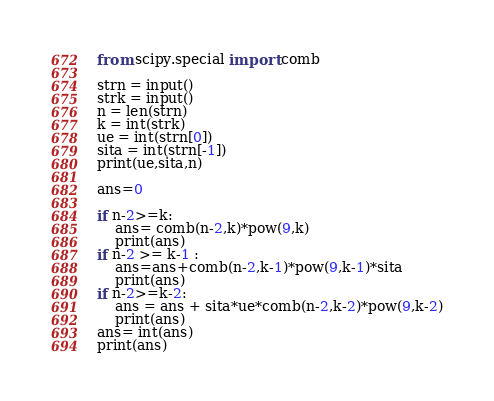Convert code to text. <code><loc_0><loc_0><loc_500><loc_500><_Python_>from scipy.special import comb

strn = input()
strk = input()
n = len(strn)
k = int(strk)
ue = int(strn[0])
sita = int(strn[-1])
print(ue,sita,n)

ans=0

if n-2>=k:
    ans= comb(n-2,k)*pow(9,k)
    print(ans)
if n-2 >= k-1 :
    ans=ans+comb(n-2,k-1)*pow(9,k-1)*sita
    print(ans)
if n-2>=k-2:
    ans = ans + sita*ue*comb(n-2,k-2)*pow(9,k-2)
    print(ans)
ans= int(ans)
print(ans)
</code> 